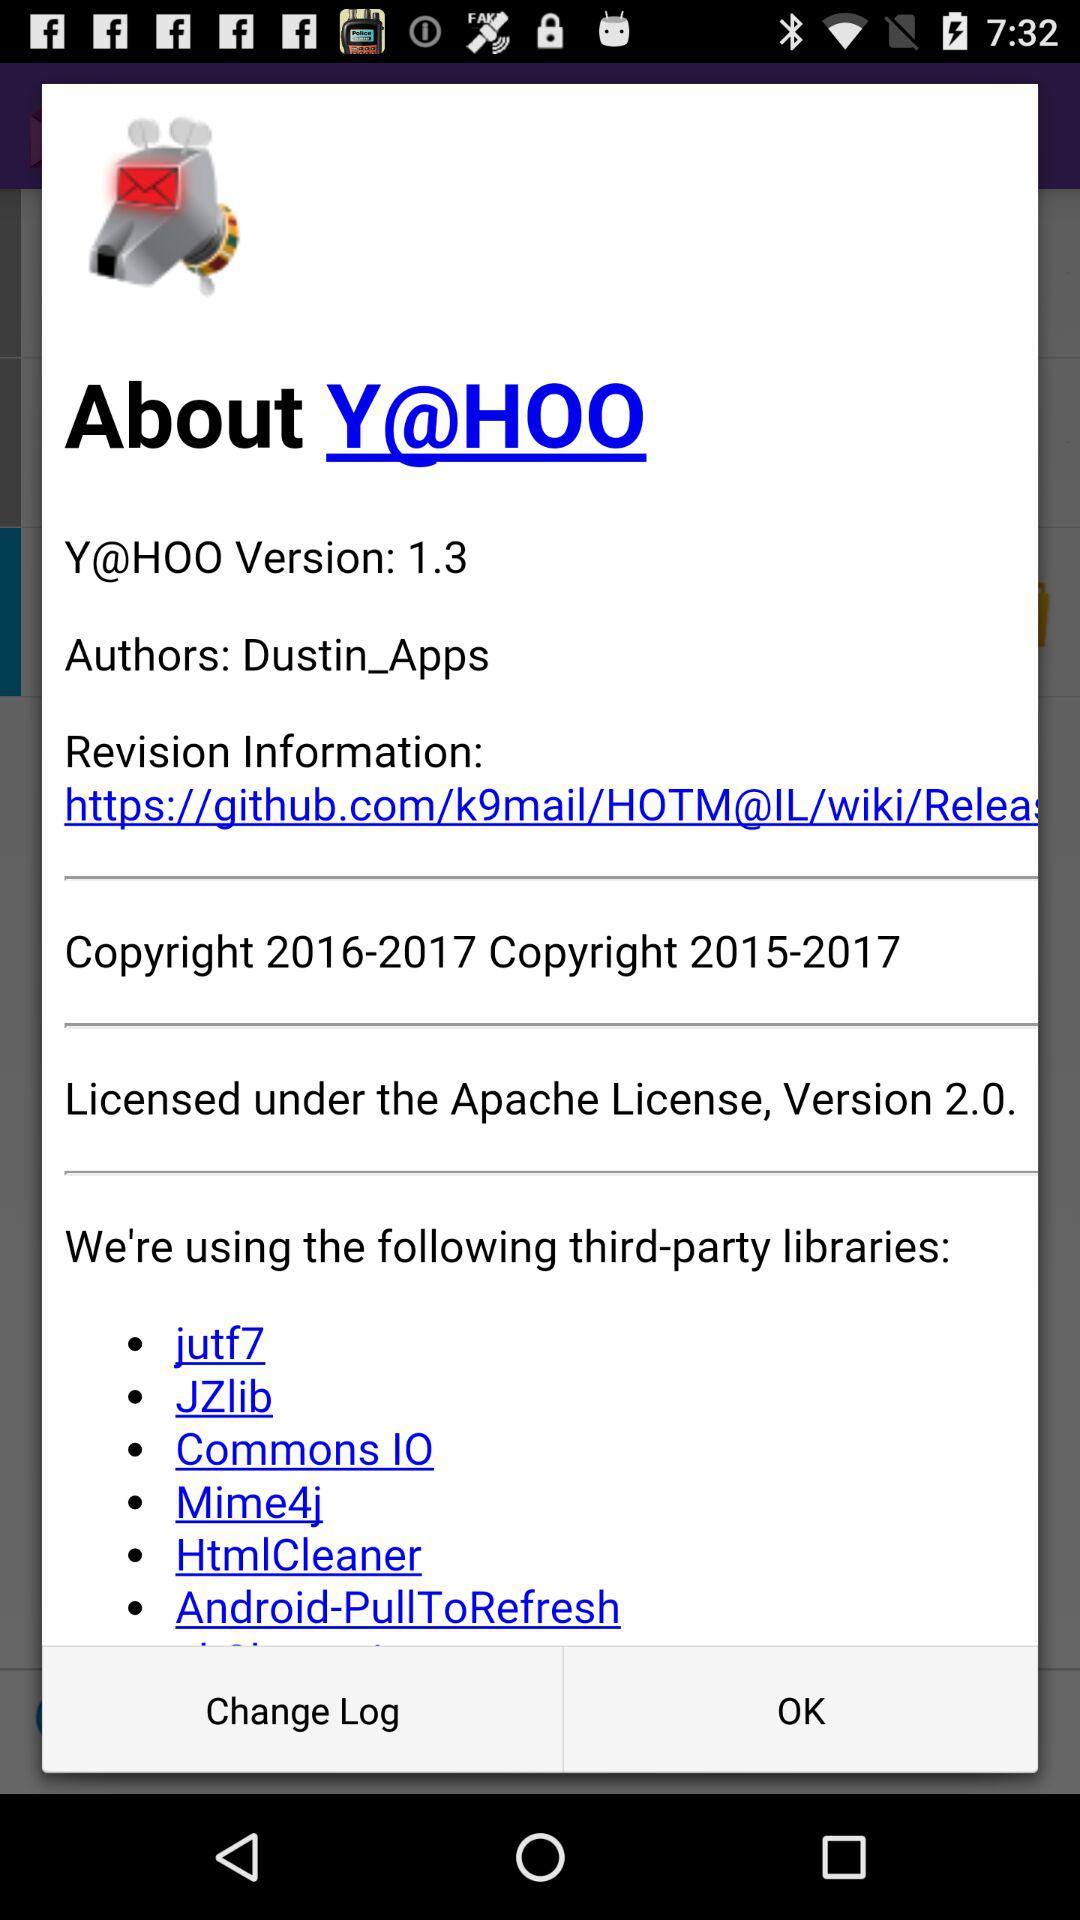Are there any downsides to using third-party libraries? While third-party libraries can be very beneficial, they also come with downsides such as potential security vulnerabilities, added complexity, possible licensing restrictions, and the risk that the library may no longer be maintained. 